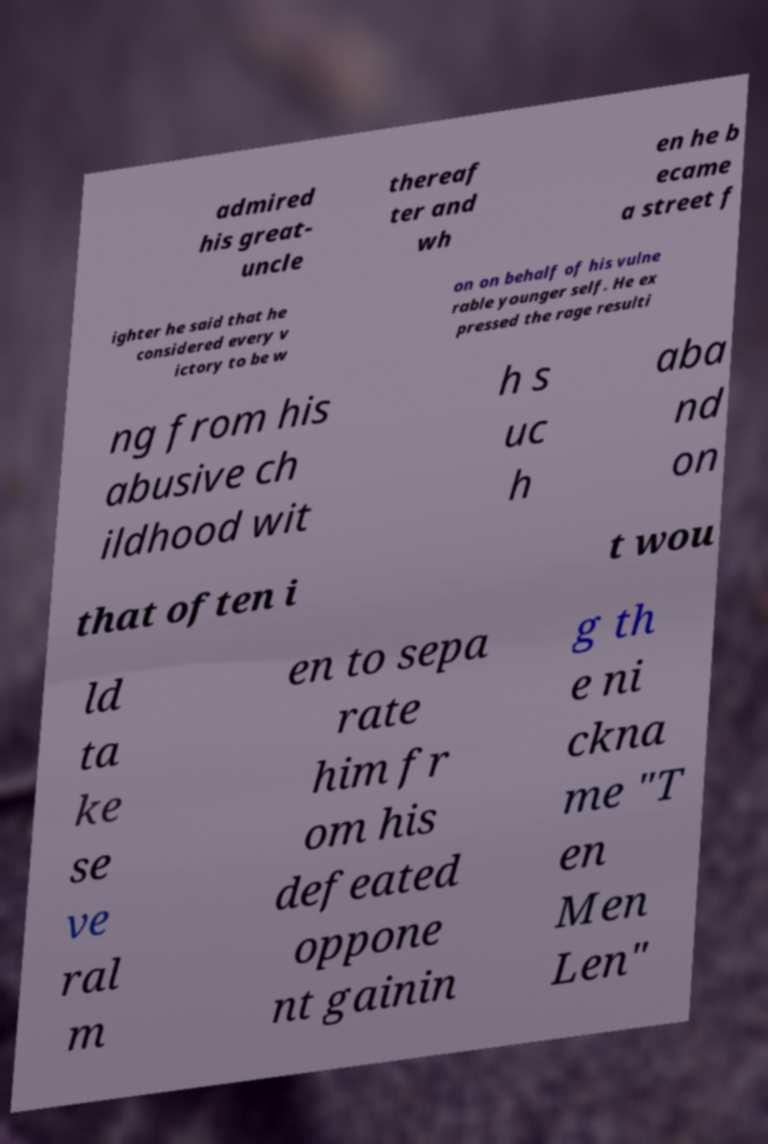For documentation purposes, I need the text within this image transcribed. Could you provide that? admired his great- uncle thereaf ter and wh en he b ecame a street f ighter he said that he considered every v ictory to be w on on behalf of his vulne rable younger self. He ex pressed the rage resulti ng from his abusive ch ildhood wit h s uc h aba nd on that often i t wou ld ta ke se ve ral m en to sepa rate him fr om his defeated oppone nt gainin g th e ni ckna me "T en Men Len" 